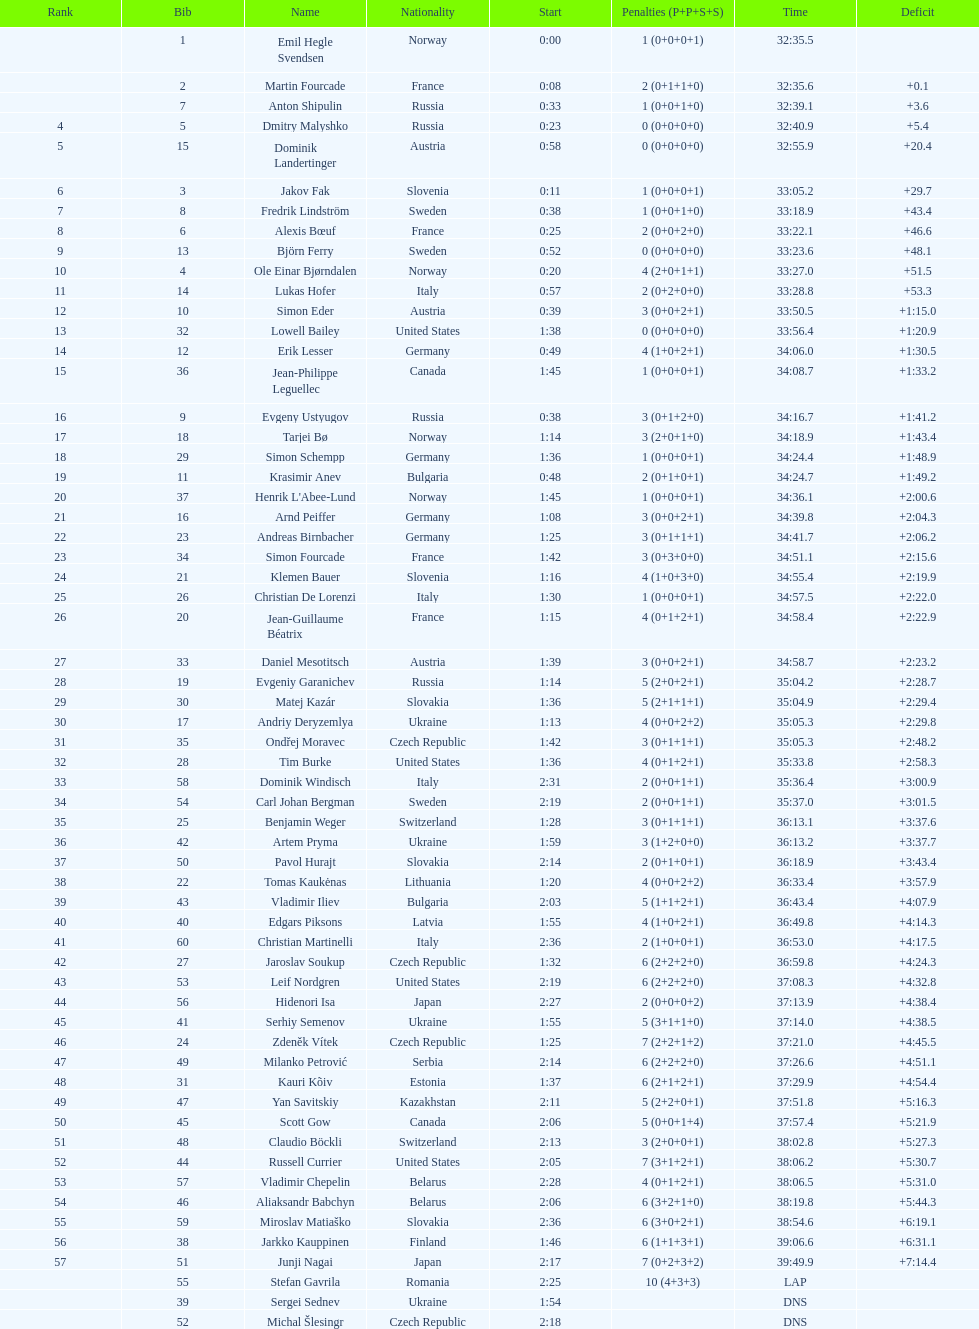Who is the highest-ranked runner from sweden? Fredrik Lindström. 